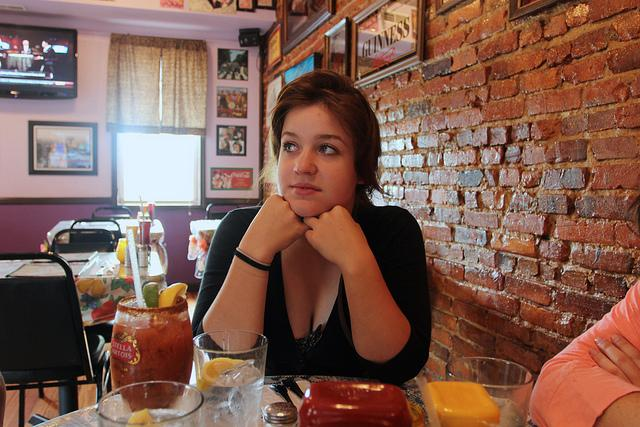What is held in the red and yellow containers on the table? Please explain your reasoning. condiments. There is mustard and ketchup in the condiment bottles. 